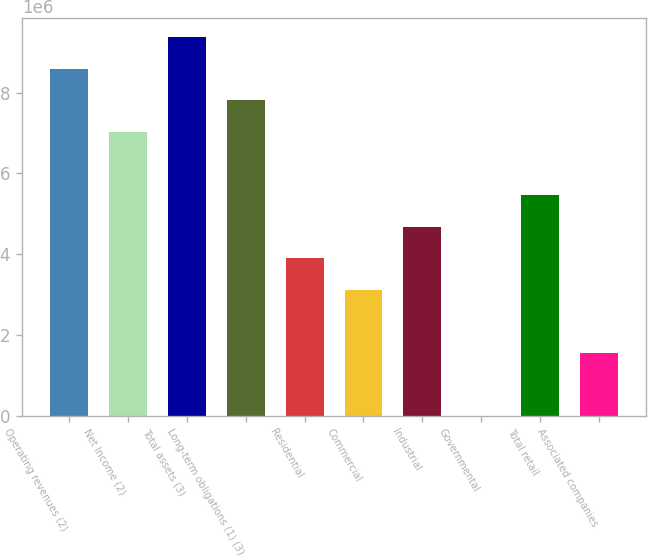Convert chart. <chart><loc_0><loc_0><loc_500><loc_500><bar_chart><fcel>Operating revenues (2)<fcel>Net Income (2)<fcel>Total assets (3)<fcel>Long-term obligations (1) (3)<fcel>Residential<fcel>Commercial<fcel>Industrial<fcel>Governmental<fcel>Total retail<fcel>Associated companies<nl><fcel>8.59044e+06<fcel>7.02855e+06<fcel>9.37139e+06<fcel>7.8095e+06<fcel>3.90477e+06<fcel>3.12382e+06<fcel>4.68571e+06<fcel>41<fcel>5.46666e+06<fcel>1.56193e+06<nl></chart> 